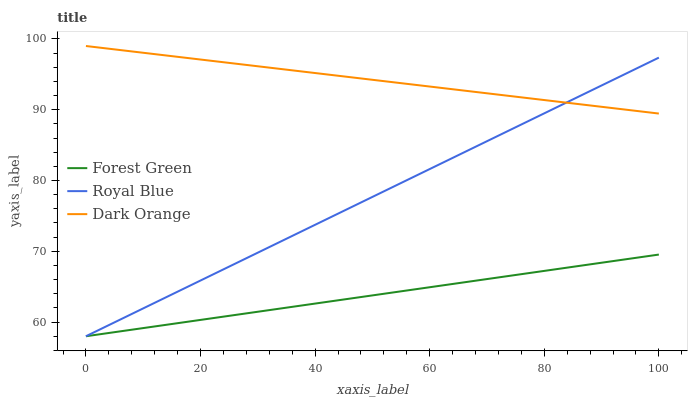Does Forest Green have the minimum area under the curve?
Answer yes or no. Yes. Does Dark Orange have the maximum area under the curve?
Answer yes or no. Yes. Does Dark Orange have the minimum area under the curve?
Answer yes or no. No. Does Forest Green have the maximum area under the curve?
Answer yes or no. No. Is Dark Orange the smoothest?
Answer yes or no. Yes. Is Royal Blue the roughest?
Answer yes or no. Yes. Is Forest Green the smoothest?
Answer yes or no. No. Is Forest Green the roughest?
Answer yes or no. No. Does Royal Blue have the lowest value?
Answer yes or no. Yes. Does Dark Orange have the lowest value?
Answer yes or no. No. Does Dark Orange have the highest value?
Answer yes or no. Yes. Does Forest Green have the highest value?
Answer yes or no. No. Is Forest Green less than Dark Orange?
Answer yes or no. Yes. Is Dark Orange greater than Forest Green?
Answer yes or no. Yes. Does Royal Blue intersect Forest Green?
Answer yes or no. Yes. Is Royal Blue less than Forest Green?
Answer yes or no. No. Is Royal Blue greater than Forest Green?
Answer yes or no. No. Does Forest Green intersect Dark Orange?
Answer yes or no. No. 